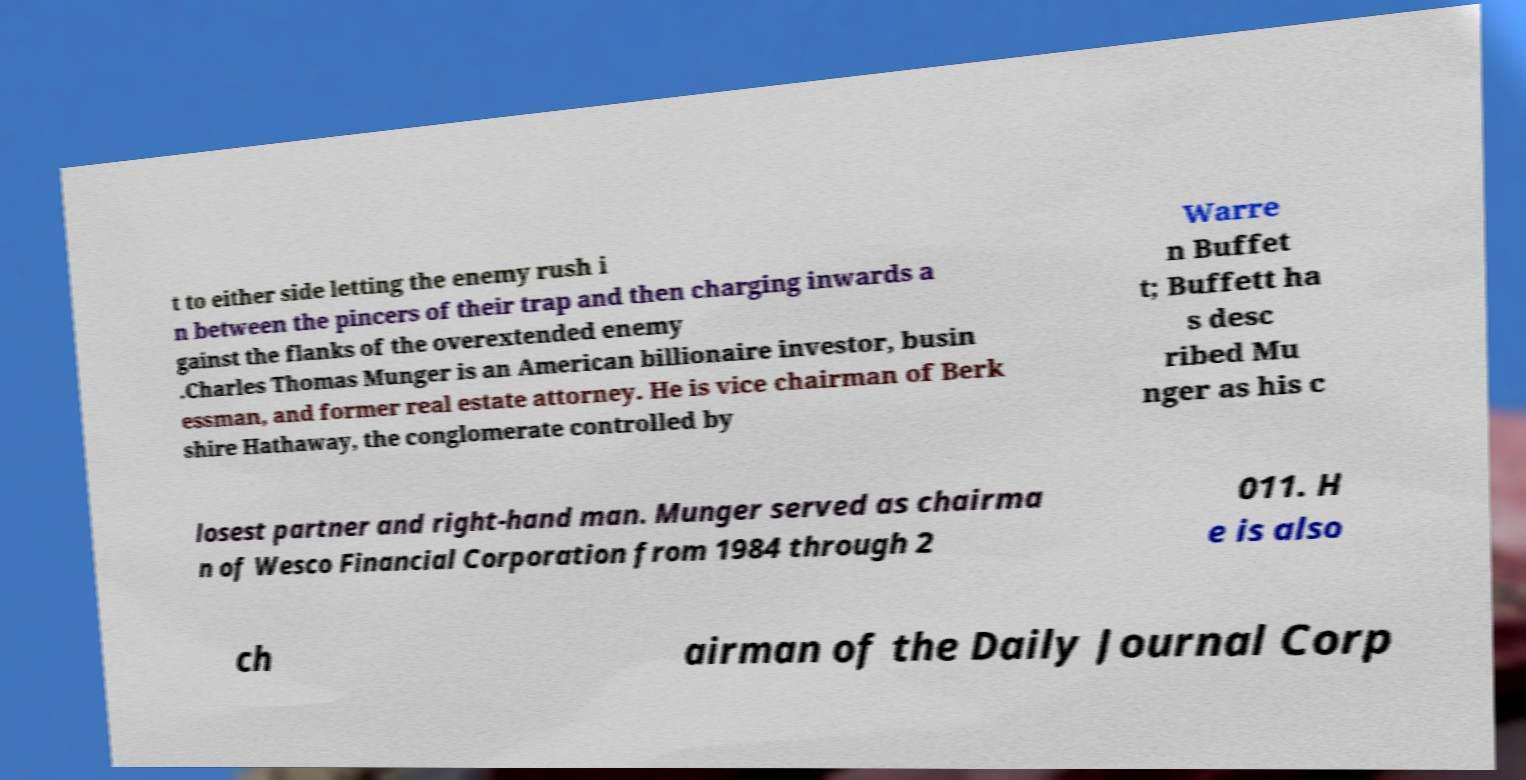What messages or text are displayed in this image? I need them in a readable, typed format. t to either side letting the enemy rush i n between the pincers of their trap and then charging inwards a gainst the flanks of the overextended enemy .Charles Thomas Munger is an American billionaire investor, busin essman, and former real estate attorney. He is vice chairman of Berk shire Hathaway, the conglomerate controlled by Warre n Buffet t; Buffett ha s desc ribed Mu nger as his c losest partner and right-hand man. Munger served as chairma n of Wesco Financial Corporation from 1984 through 2 011. H e is also ch airman of the Daily Journal Corp 